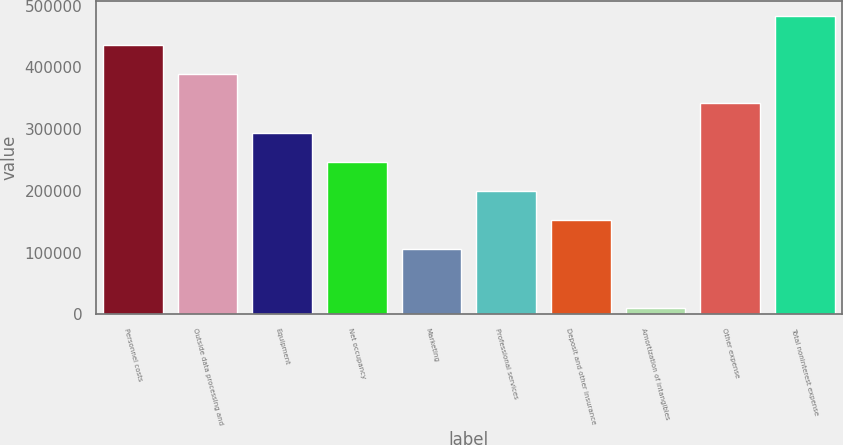Convert chart. <chart><loc_0><loc_0><loc_500><loc_500><bar_chart><fcel>Personnel costs<fcel>Outside data processing and<fcel>Equipment<fcel>Net occupancy<fcel>Marketing<fcel>Professional services<fcel>Deposit and other insurance<fcel>Amortization of intangibles<fcel>Other expense<fcel>Total noninterest expense<nl><fcel>436009<fcel>388747<fcel>294224<fcel>246962<fcel>105177<fcel>199700<fcel>152438<fcel>10653<fcel>341486<fcel>483271<nl></chart> 